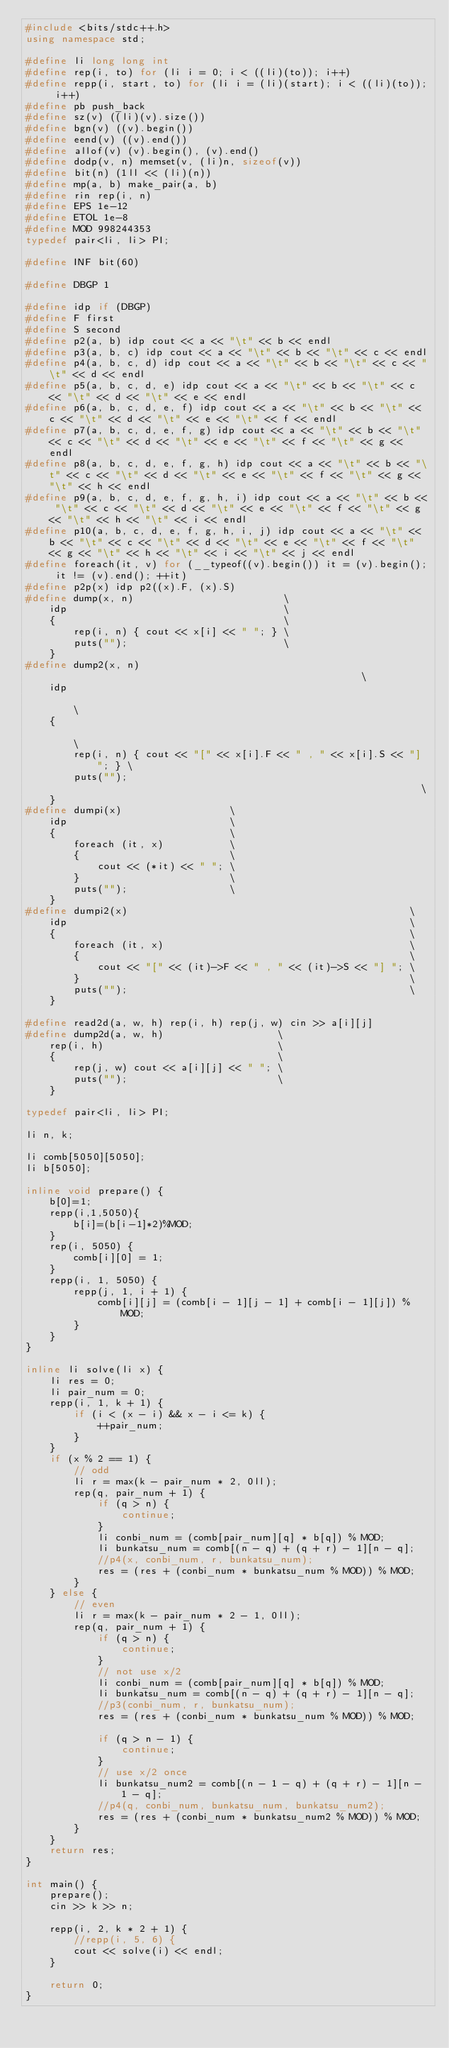Convert code to text. <code><loc_0><loc_0><loc_500><loc_500><_C++_>#include <bits/stdc++.h>
using namespace std;

#define li long long int
#define rep(i, to) for (li i = 0; i < ((li)(to)); i++)
#define repp(i, start, to) for (li i = (li)(start); i < ((li)(to)); i++)
#define pb push_back
#define sz(v) ((li)(v).size())
#define bgn(v) ((v).begin())
#define eend(v) ((v).end())
#define allof(v) (v).begin(), (v).end()
#define dodp(v, n) memset(v, (li)n, sizeof(v))
#define bit(n) (1ll << (li)(n))
#define mp(a, b) make_pair(a, b)
#define rin rep(i, n)
#define EPS 1e-12
#define ETOL 1e-8
#define MOD 998244353
typedef pair<li, li> PI;

#define INF bit(60)

#define DBGP 1

#define idp if (DBGP)
#define F first
#define S second
#define p2(a, b) idp cout << a << "\t" << b << endl
#define p3(a, b, c) idp cout << a << "\t" << b << "\t" << c << endl
#define p4(a, b, c, d) idp cout << a << "\t" << b << "\t" << c << "\t" << d << endl
#define p5(a, b, c, d, e) idp cout << a << "\t" << b << "\t" << c << "\t" << d << "\t" << e << endl
#define p6(a, b, c, d, e, f) idp cout << a << "\t" << b << "\t" << c << "\t" << d << "\t" << e << "\t" << f << endl
#define p7(a, b, c, d, e, f, g) idp cout << a << "\t" << b << "\t" << c << "\t" << d << "\t" << e << "\t" << f << "\t" << g << endl
#define p8(a, b, c, d, e, f, g, h) idp cout << a << "\t" << b << "\t" << c << "\t" << d << "\t" << e << "\t" << f << "\t" << g << "\t" << h << endl
#define p9(a, b, c, d, e, f, g, h, i) idp cout << a << "\t" << b << "\t" << c << "\t" << d << "\t" << e << "\t" << f << "\t" << g << "\t" << h << "\t" << i << endl
#define p10(a, b, c, d, e, f, g, h, i, j) idp cout << a << "\t" << b << "\t" << c << "\t" << d << "\t" << e << "\t" << f << "\t" << g << "\t" << h << "\t" << i << "\t" << j << endl
#define foreach(it, v) for (__typeof((v).begin()) it = (v).begin(); it != (v).end(); ++it)
#define p2p(x) idp p2((x).F, (x).S)
#define dump(x, n)                         \
    idp                                    \
    {                                      \
        rep(i, n) { cout << x[i] << " "; } \
        puts("");                          \
    }
#define dump2(x, n)                                                     \
    idp                                                                 \
    {                                                                   \
        rep(i, n) { cout << "[" << x[i].F << " , " << x[i].S << "] "; } \
        puts("");                                                       \
    }
#define dumpi(x)                  \
    idp                           \
    {                             \
        foreach (it, x)           \
        {                         \
            cout << (*it) << " "; \
        }                         \
        puts("");                 \
    }
#define dumpi2(x)                                               \
    idp                                                         \
    {                                                           \
        foreach (it, x)                                         \
        {                                                       \
            cout << "[" << (it)->F << " , " << (it)->S << "] "; \
        }                                                       \
        puts("");                                               \
    }

#define read2d(a, w, h) rep(i, h) rep(j, w) cin >> a[i][j]
#define dump2d(a, w, h)                   \
    rep(i, h)                             \
    {                                     \
        rep(j, w) cout << a[i][j] << " "; \
        puts("");                         \
    }

typedef pair<li, li> PI;

li n, k;

li comb[5050][5050];
li b[5050];

inline void prepare() {
    b[0]=1;
    repp(i,1,5050){
        b[i]=(b[i-1]*2)%MOD;
    }
    rep(i, 5050) {
        comb[i][0] = 1;
    }
    repp(i, 1, 5050) {
        repp(j, 1, i + 1) {
            comb[i][j] = (comb[i - 1][j - 1] + comb[i - 1][j]) % MOD;
        }
    }
}

inline li solve(li x) {
    li res = 0;
    li pair_num = 0;
    repp(i, 1, k + 1) {
        if (i < (x - i) && x - i <= k) {
            ++pair_num;
        }
    }
    if (x % 2 == 1) {
        // odd
        li r = max(k - pair_num * 2, 0ll);
        rep(q, pair_num + 1) {
            if (q > n) {
                continue;
            }
            li conbi_num = (comb[pair_num][q] * b[q]) % MOD;
            li bunkatsu_num = comb[(n - q) + (q + r) - 1][n - q];
            //p4(x, conbi_num, r, bunkatsu_num);
            res = (res + (conbi_num * bunkatsu_num % MOD)) % MOD;
        }
    } else {
        // even
        li r = max(k - pair_num * 2 - 1, 0ll);
        rep(q, pair_num + 1) {
            if (q > n) {
                continue;
            }
            // not use x/2
            li conbi_num = (comb[pair_num][q] * b[q]) % MOD;
            li bunkatsu_num = comb[(n - q) + (q + r) - 1][n - q];
            //p3(conbi_num, r, bunkatsu_num);
            res = (res + (conbi_num * bunkatsu_num % MOD)) % MOD;

            if (q > n - 1) {
                continue;
            }
            // use x/2 once
            li bunkatsu_num2 = comb[(n - 1 - q) + (q + r) - 1][n - 1 - q];
            //p4(q, conbi_num, bunkatsu_num, bunkatsu_num2);
            res = (res + (conbi_num * bunkatsu_num2 % MOD)) % MOD;
        }
    }
    return res;
}

int main() {
    prepare();
    cin >> k >> n;

    repp(i, 2, k * 2 + 1) {
        //repp(i, 5, 6) {
        cout << solve(i) << endl;
    }

    return 0;
}
</code> 